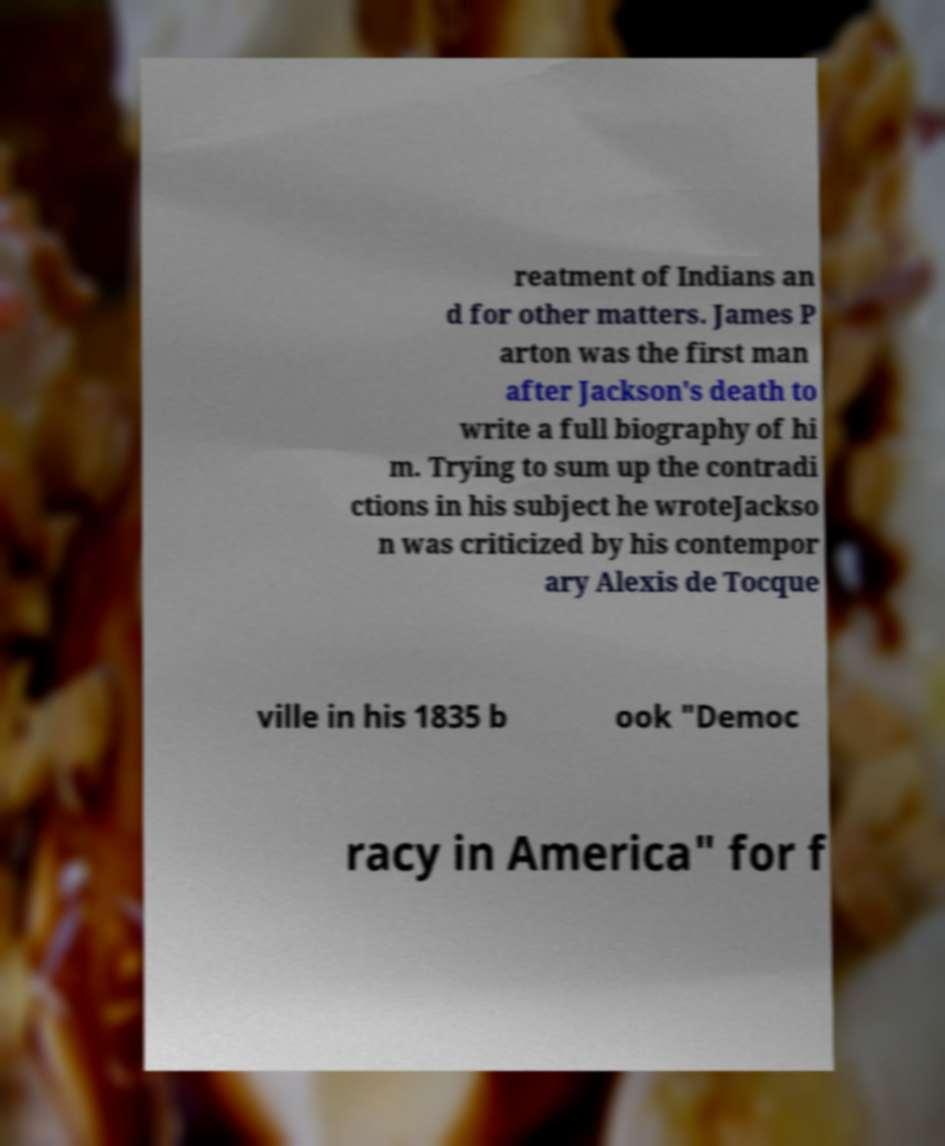There's text embedded in this image that I need extracted. Can you transcribe it verbatim? reatment of Indians an d for other matters. James P arton was the first man after Jackson's death to write a full biography of hi m. Trying to sum up the contradi ctions in his subject he wroteJackso n was criticized by his contempor ary Alexis de Tocque ville in his 1835 b ook "Democ racy in America" for f 